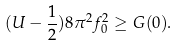Convert formula to latex. <formula><loc_0><loc_0><loc_500><loc_500>( U - \frac { 1 } { 2 } ) 8 \pi ^ { 2 } f _ { 0 } ^ { 2 } \geq G ( 0 ) .</formula> 